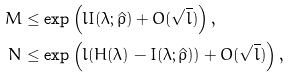Convert formula to latex. <formula><loc_0><loc_0><loc_500><loc_500>M & \leq \exp \left ( l I ( \lambda ; \hat { \rho } ) + O ( \sqrt { l } ) \right ) , \\ N & \leq \exp \left ( l ( H ( \lambda ) - I ( \lambda ; \hat { \rho } ) ) + O ( \sqrt { l } ) \right ) ,</formula> 